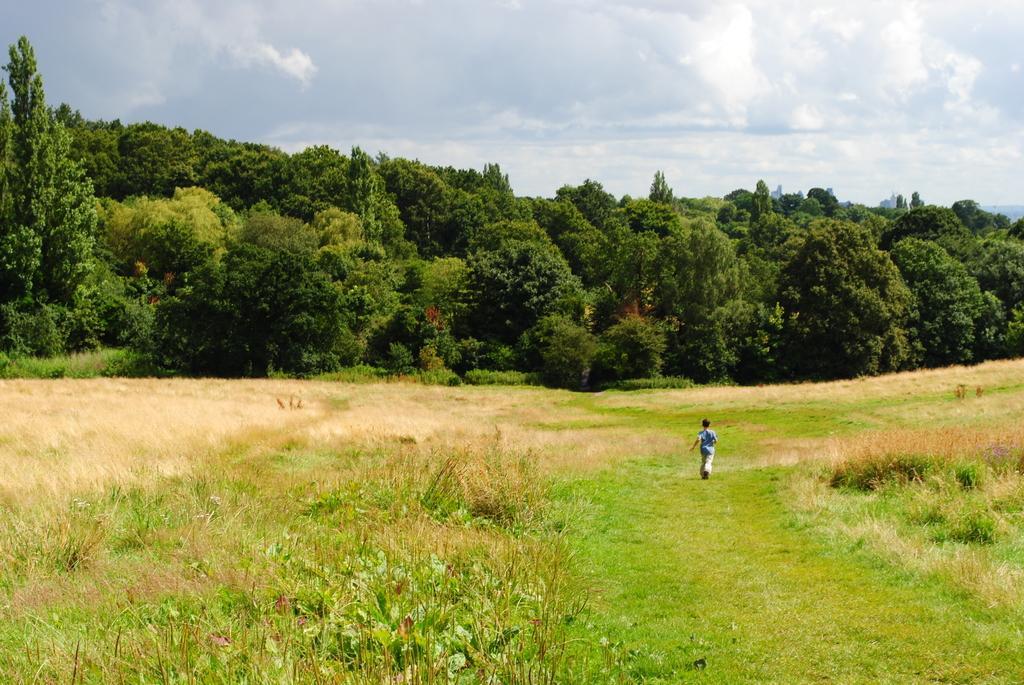Could you give a brief overview of what you see in this image? In the center of the image there is a boy running. At the bottom of the image there is grass. There are plants. In the background of the image there are trees. At the top of the image there is sky and clouds. 